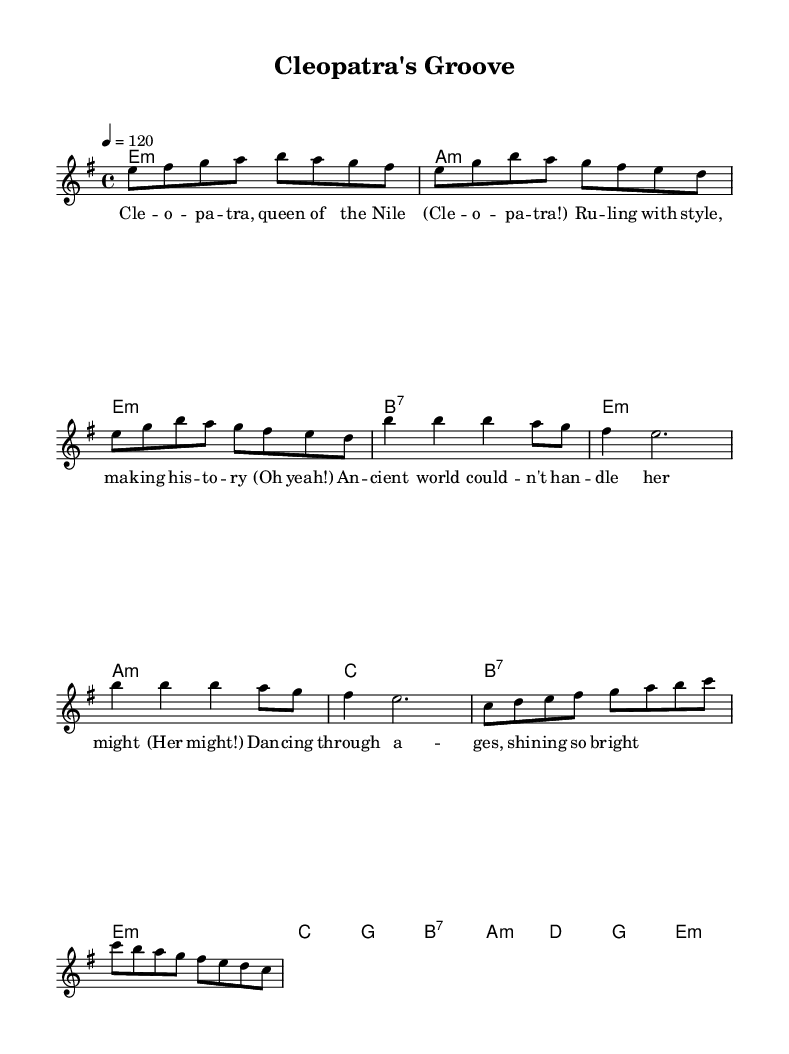What is the key signature of this music? The key signature is E minor, which has one sharp (F#). This is indicated at the beginning of the sheet music where the key signature symbols are placed.
Answer: E minor What is the time signature of this piece? The time signature is 4/4, which means there are four beats per measure and the quarter note gets one beat. This is shown at the beginning of the sheet music written as a fraction.
Answer: 4/4 What is the tempo marking (bpm) for this composition? The tempo marking is 120 beats per minute, specified where it indicates "4 = 120" in the global settings. This informs performers about the intended speed of the music.
Answer: 120 How many measures are in the chorus section? The chorus section consists of 4 measures, as identified by the notation provided within the score and the lyrics lines corresponding to those measures.
Answer: 4 What type of form is primarily used in this piece? The primary form of the piece is verse-chorus-verse-chorus, which can be deduced from the organization of the sections labeled in the sheet music. Each section alternates between verses and choruses.
Answer: Verse-chorus What is the emotional tone conveyed in the lyrics? The emotional tone conveyed in the lyrics is empowerment, as the lyrics celebrate Cleopatra’s strength and historical significance. This interpretation comes from the repetition of powerful words and themes apparent in the lyrical content.
Answer: Empowerment Which instrument is indicated to play the melody? The instrument indicated to play the melody is a voice, as noted in the score where "new Voice = 'lead'" is specified. This suggests that the melody is meant for singing.
Answer: Voice 